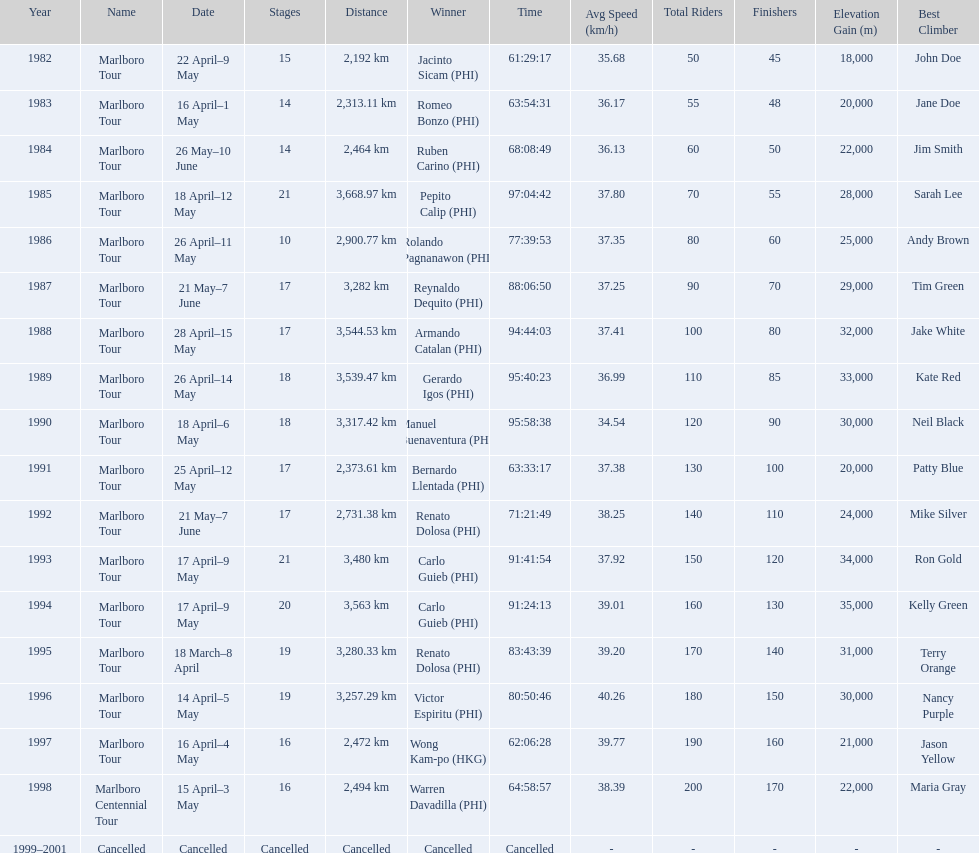How long did it take warren davadilla to complete the 1998 marlboro centennial tour? 64:58:57. 